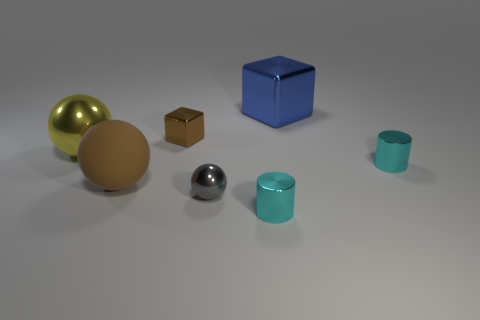How would you relate the objects in the picture to items we use every day? These objects seem to represent simple geometric shapes that can be associated with various everyday items. The golden sphere might remind us of decorative items or playful spheres like balls. The small brown cube could resemble a package or a small wooden block. The solid blue cube could be akin to a large storage box or toy block. The shiny chrome sphere could represent a sleek, modern touch like a metal doorknob or a piece of contemporary art. Finally, the teal cylinder might relate to a container, such as a pencil holder or a cup. 